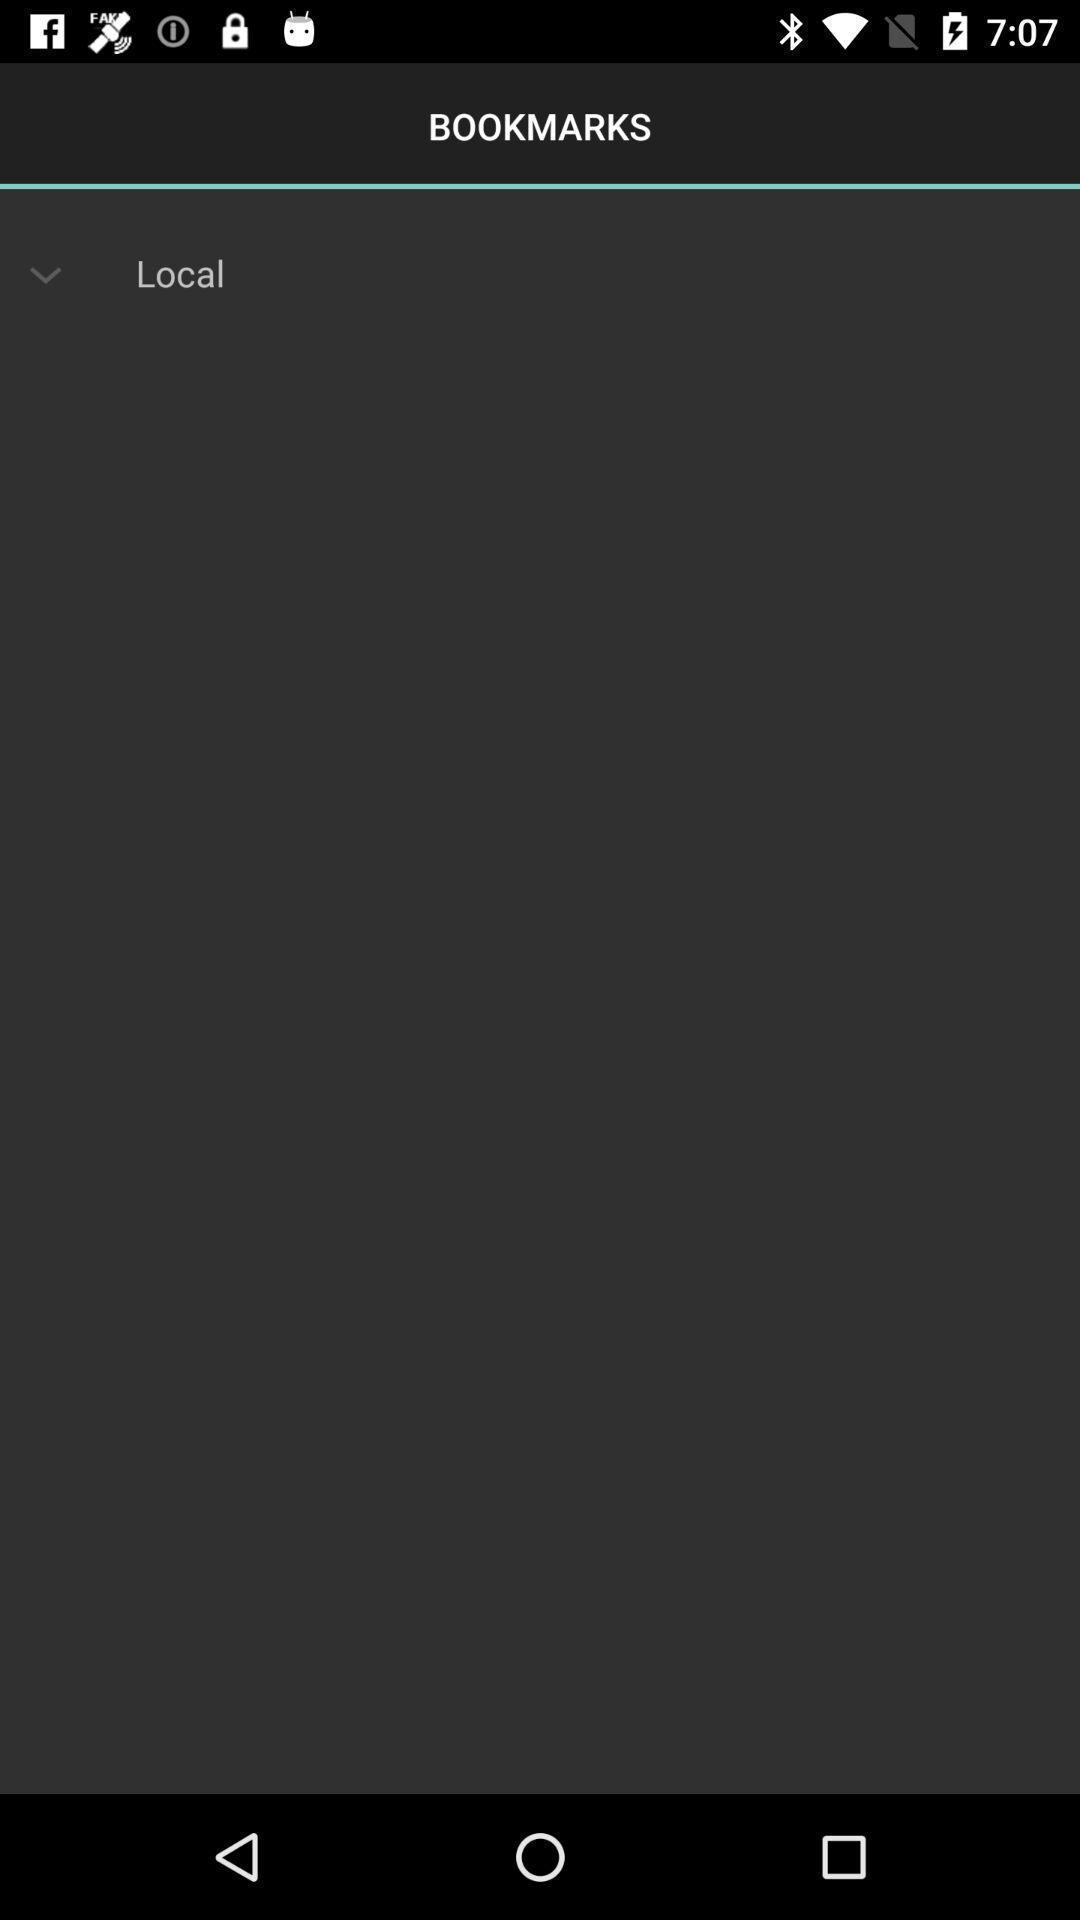Provide a description of this screenshot. Page showing information about bookmarks. 